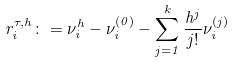Convert formula to latex. <formula><loc_0><loc_0><loc_500><loc_500>r ^ { \tau , h } _ { i } \colon = \nu ^ { h } _ { i } - \nu ^ { ( 0 ) } _ { i } - \sum _ { j = 1 } ^ { k } \frac { h ^ { j } } { j ! } \nu ^ { ( j ) } _ { i }</formula> 